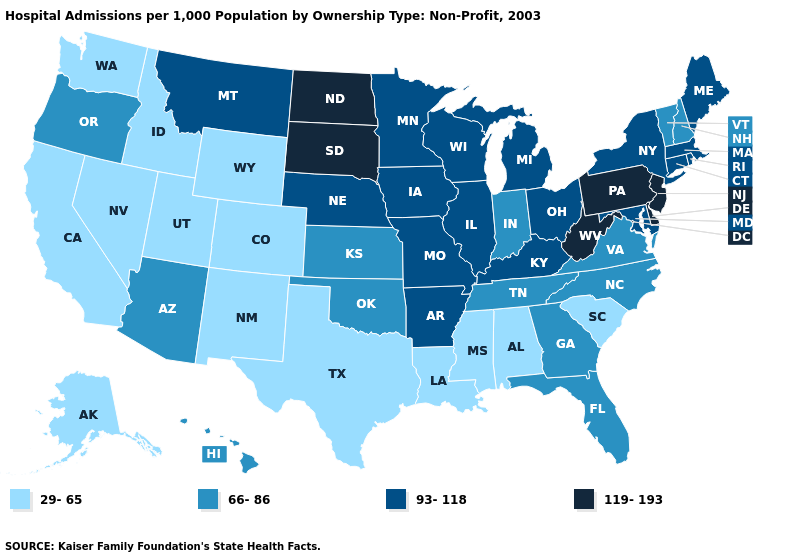Name the states that have a value in the range 29-65?
Concise answer only. Alabama, Alaska, California, Colorado, Idaho, Louisiana, Mississippi, Nevada, New Mexico, South Carolina, Texas, Utah, Washington, Wyoming. Name the states that have a value in the range 66-86?
Keep it brief. Arizona, Florida, Georgia, Hawaii, Indiana, Kansas, New Hampshire, North Carolina, Oklahoma, Oregon, Tennessee, Vermont, Virginia. Does the map have missing data?
Answer briefly. No. Which states have the lowest value in the West?
Be succinct. Alaska, California, Colorado, Idaho, Nevada, New Mexico, Utah, Washington, Wyoming. Name the states that have a value in the range 119-193?
Keep it brief. Delaware, New Jersey, North Dakota, Pennsylvania, South Dakota, West Virginia. What is the value of Illinois?
Quick response, please. 93-118. What is the highest value in states that border West Virginia?
Quick response, please. 119-193. Name the states that have a value in the range 66-86?
Keep it brief. Arizona, Florida, Georgia, Hawaii, Indiana, Kansas, New Hampshire, North Carolina, Oklahoma, Oregon, Tennessee, Vermont, Virginia. What is the value of West Virginia?
Give a very brief answer. 119-193. What is the value of Washington?
Concise answer only. 29-65. Is the legend a continuous bar?
Short answer required. No. Does Alaska have the lowest value in the USA?
Concise answer only. Yes. Does Indiana have a higher value than Nevada?
Quick response, please. Yes. What is the highest value in the West ?
Give a very brief answer. 93-118. Does Kansas have a lower value than Illinois?
Give a very brief answer. Yes. 